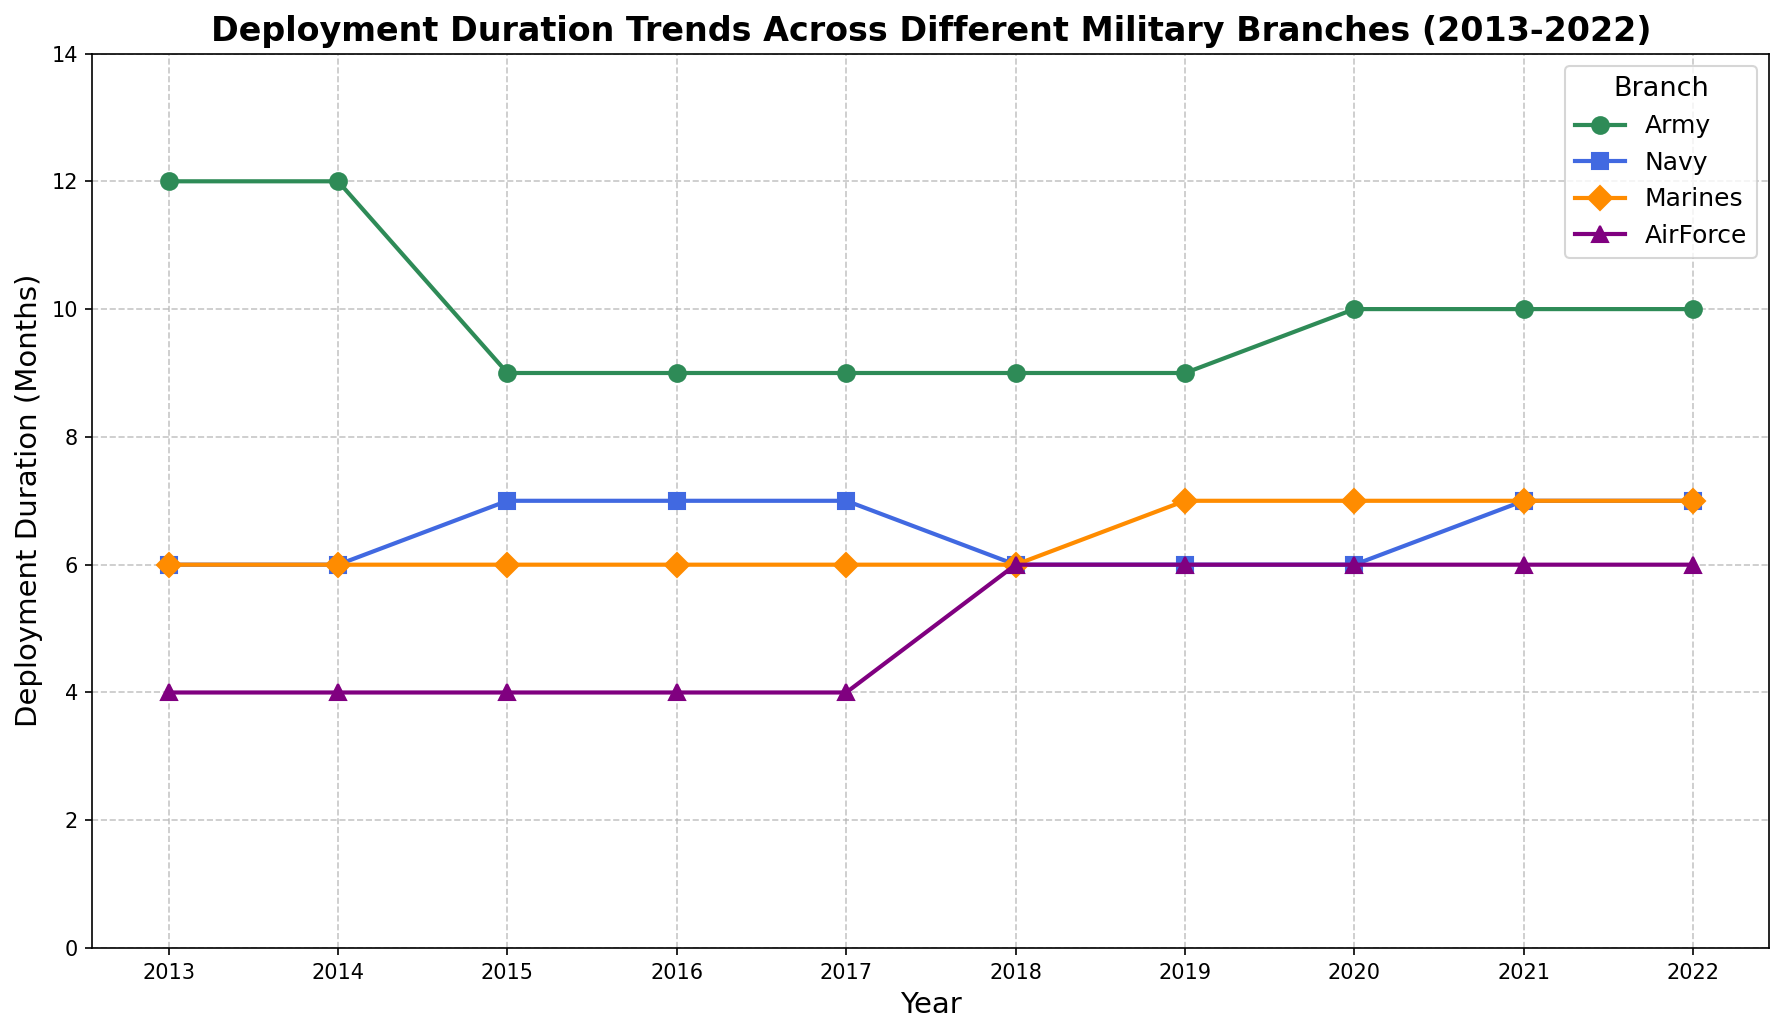Which branch had the longest average deployment duration from 2013 to 2022? To find this, take the deployment durations for each branch over the years and calculate the average. For the Army, it’s (12+12+9+9+9+9+9+10+10+10)/10 = 9.9 months. For the Navy, it’s (6+6+7+7+7+6+6+6+7+7)/10 = 6.5 months. For the Marines, it’s (6+6+6+6+6+6+7+7+7+7)/10 = 6.4 months. For the Air Force, it’s (4+4+4+4+4+6+6+6+6+6)/10 = 5.2 months. The Army had the longest average deployment duration.
Answer: The Army Which branch had the shortest deployment duration at any point between 2013 and 2022? Examine the minimum deployment durations for each branch over the years: Army (9 months in 2015 to 2019), Navy (6 months in 2013, 2014, 2018, 2019, and 2020), Marines (6 months in 2013 to 2018), and Air Force (4 months in 2013 to 2017). The Air Force had the shortest deployment duration of 4 months.
Answer: The Air Force How did the deployment duration for the Navy change from 2013 to 2022? To find how the deployment duration for the Navy changed over the years, examine the trend line for the Navy. In 2013 and 2014, it was 6 months; in 2015 it increased to 7 months; it stayed constant in 2016 and 2017; then reduced to 6 in 2018 and 2019 and remained steady. It then increased to 7 in 2021 and 2022.
Answer: It fluctuated between 6 and 7 months Which branch experienced an increase in deployment duration after 2017? To identify which branches experienced increases after 2017, examine the trend for each branch. Only the Army (increased from 9 to 10 months in 2020 and onwards), the Marines (increased from 6 to 7 in 2019), and the Air Force (increased from 4 to 6 months in 2018 and onwards) show increases.
Answer: Army, Marines, and Air Force Compare the deployment durations of the Army and Air Force in 2022. Which is longer? Look at the data points for the year 2022 for both Army (10 months) and Air Force (6 months). The Army’s deployment duration is longer.
Answer: The Army In what year did the Marines first experience a change in deployment duration? To determine when the Marines' deployment duration first changed, look at the data for the Marines. The duration was steady at 6 months from 2013 through 2018 and increased to 7 months in 2019.
Answer: 2019 What was the deployment duration trend for the Air Force from 2013 to 2022? Examine the data points for the Air Force. For 2013 to 2017, it was constant at 4 months; then it increased to 6 months in 2018 and remained constant until 2022.
Answer: From 4 to 6 months, then constant Which branch had the most stable deployment duration over the decade? To determine stability, look for the branch with the least change in deployment duration over the years. The Marines had the smallest change, remaining at 6 months from 2013 to 2018 and 7 months thereafter.
Answer: The Marines What is the difference in deployment duration between the Army and Marines in 2015? Look at the data points for 2015: Army (9 months) and Marines (6 months). The difference is 9 - 6 = 3 months.
Answer: 3 months 